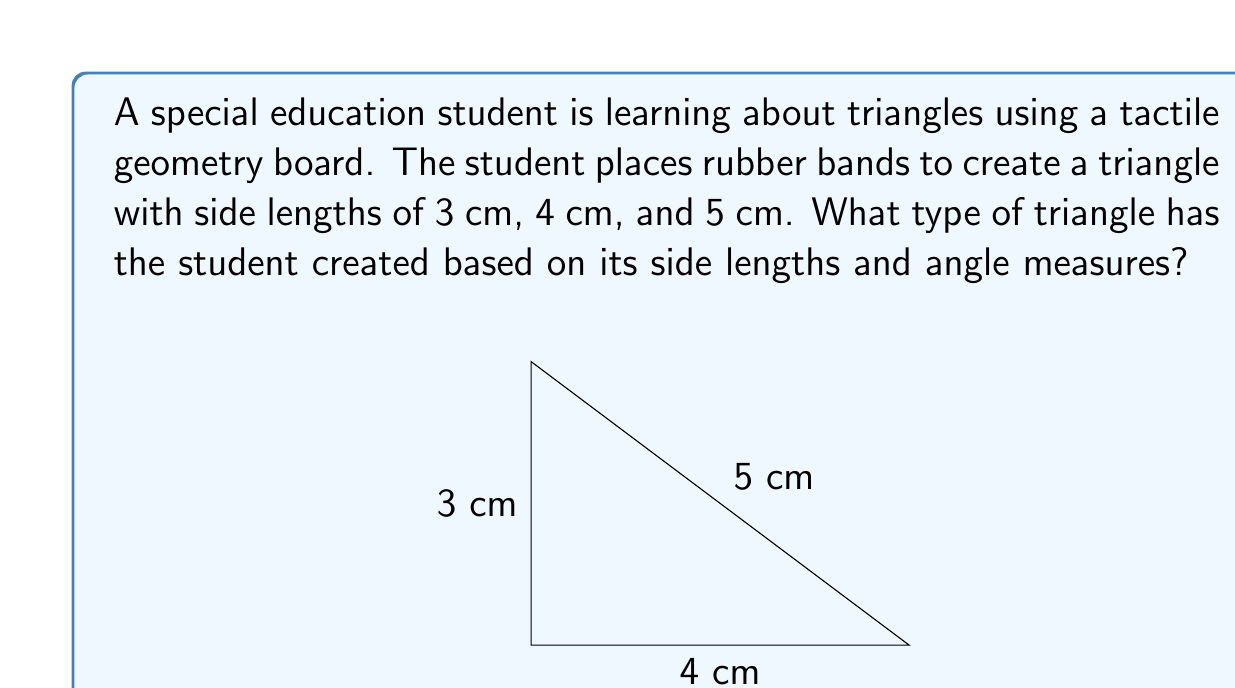Give your solution to this math problem. Let's approach this step-by-step:

1) First, we need to classify the triangle based on its side lengths:
   - The triangle has side lengths of 3 cm, 4 cm, and 5 cm.
   - Since all side lengths are different, this is a scalene triangle.

2) Next, we need to determine if it's a right triangle:
   - We can use the Pythagorean theorem to check: $a^2 + b^2 = c^2$
   - Let's substitute our values: $3^2 + 4^2 \stackrel{?}{=} 5^2$
   - $9 + 16 = 25$
   - $25 = 25$
   - This equality holds true, so it is a right triangle.

3) To confirm the right angle, we can calculate the cosine of the largest angle:
   - Using the cosine law: $\cos C = \frac{a^2 + b^2 - c^2}{2ab}$
   - $\cos C = \frac{3^2 + 4^2 - 5^2}{2(3)(4)} = \frac{9 + 16 - 25}{24} = 0$
   - $\cos C = 0$ implies that $C = 90°$, confirming it's a right angle.

4) Combining our findings:
   - The triangle is scalene (all sides different lengths)
   - The triangle is right-angled (has a 90° angle)

Therefore, the student has created a right scalene triangle.
Answer: Right scalene triangle 